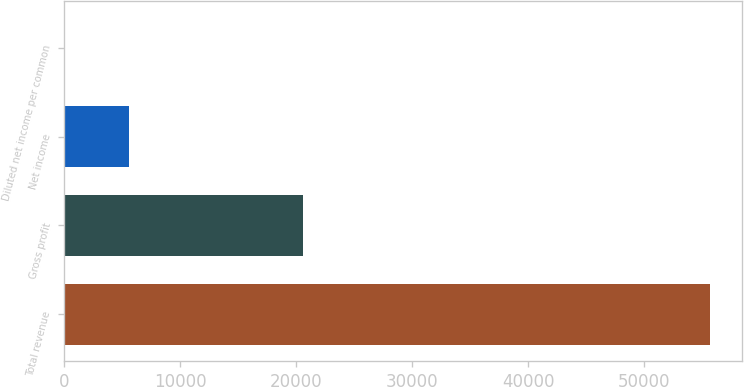<chart> <loc_0><loc_0><loc_500><loc_500><bar_chart><fcel>Total revenue<fcel>Gross profit<fcel>Net income<fcel>Diluted net income per common<nl><fcel>55648<fcel>20591<fcel>5564.85<fcel>0.06<nl></chart> 